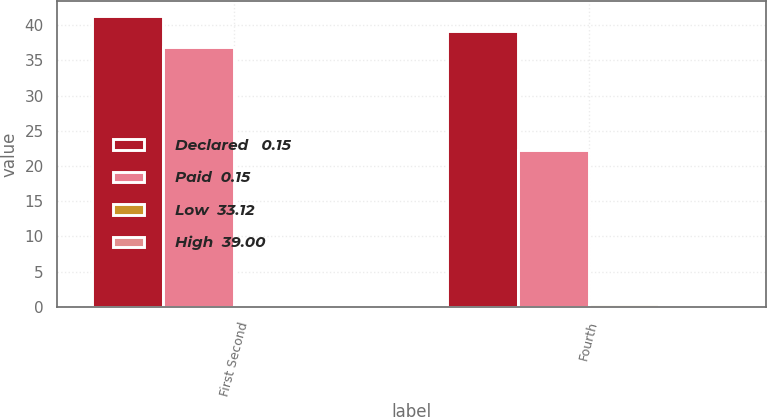<chart> <loc_0><loc_0><loc_500><loc_500><stacked_bar_chart><ecel><fcel>First Second<fcel>Fourth<nl><fcel>Declared   0.15<fcel>41.34<fcel>39.23<nl><fcel>Paid  0.15<fcel>36.85<fcel>22.25<nl><fcel>Low  33.12<fcel>0.19<fcel>0.38<nl><fcel>High  39.00<fcel>0.15<fcel>0.19<nl></chart> 